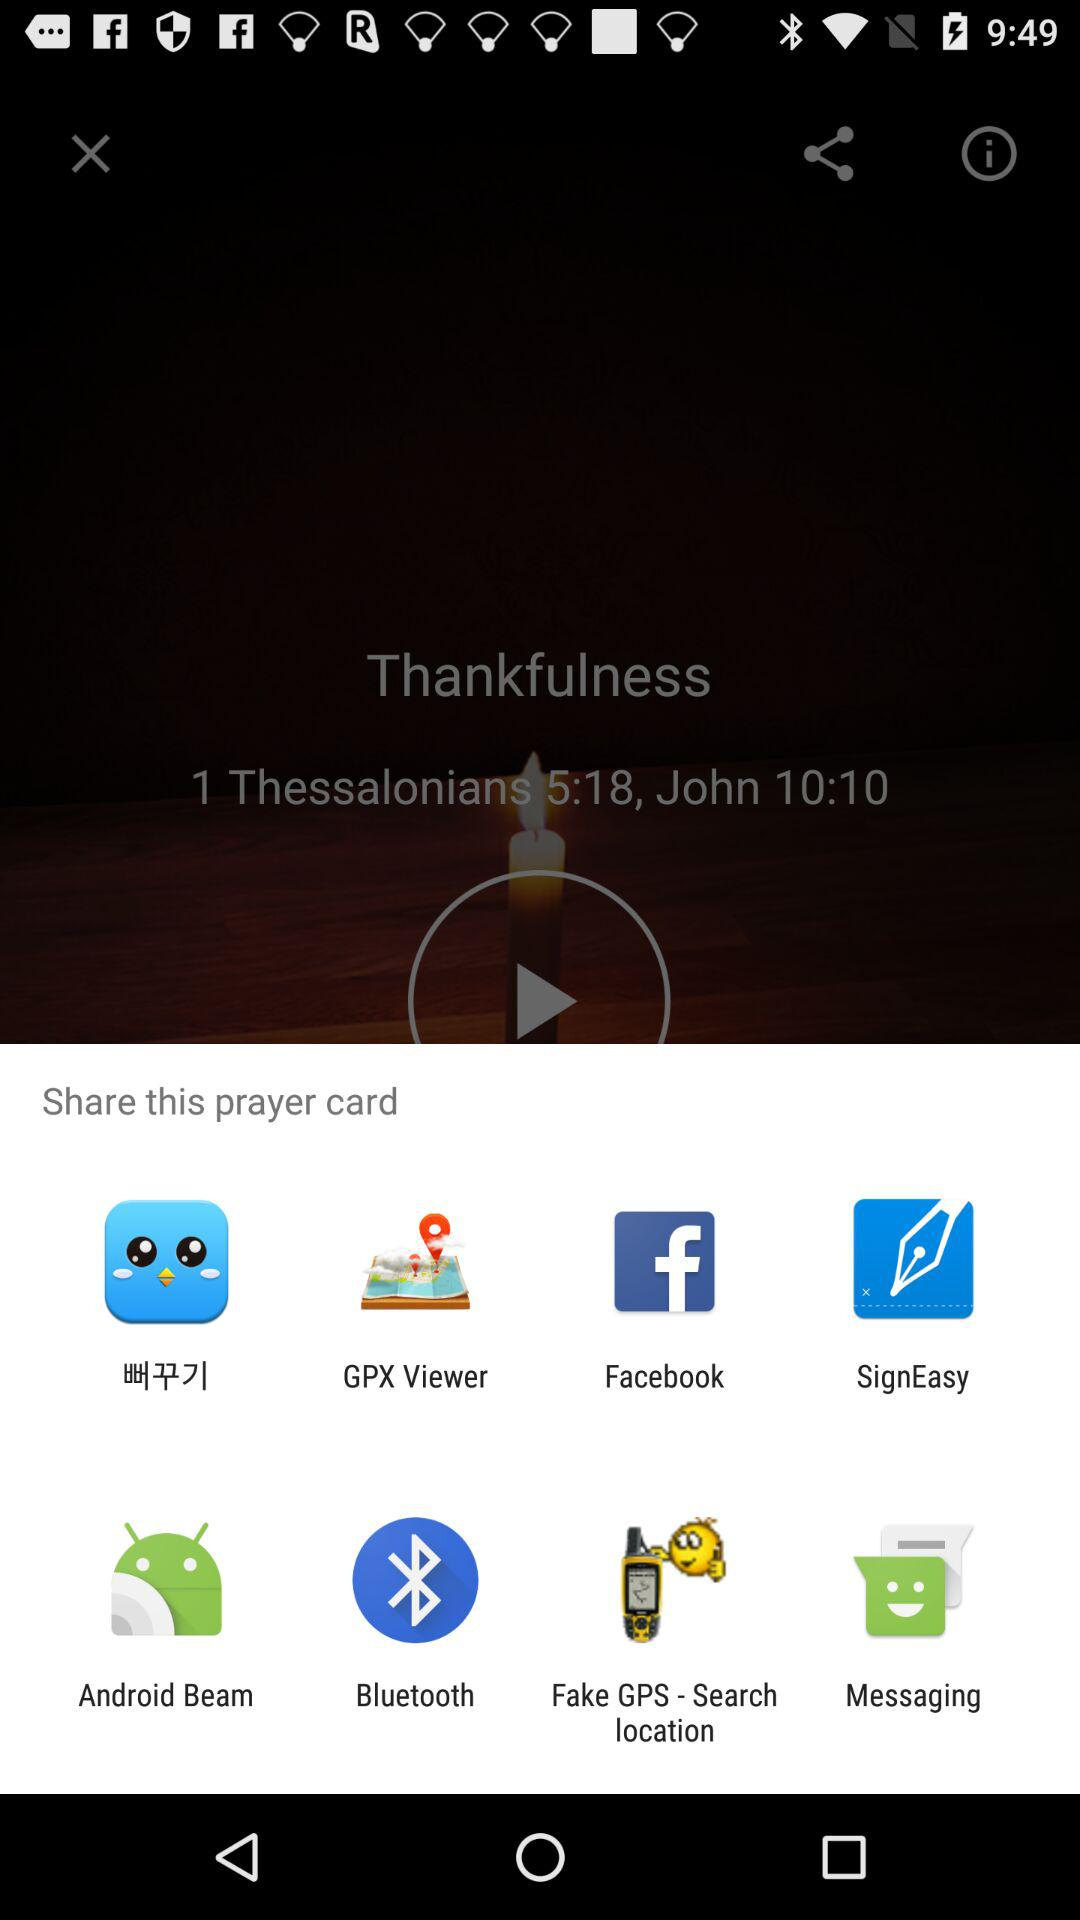Through which applications can we share the prayer card?
When the provided information is insufficient, respond with <no answer>. <no answer> 